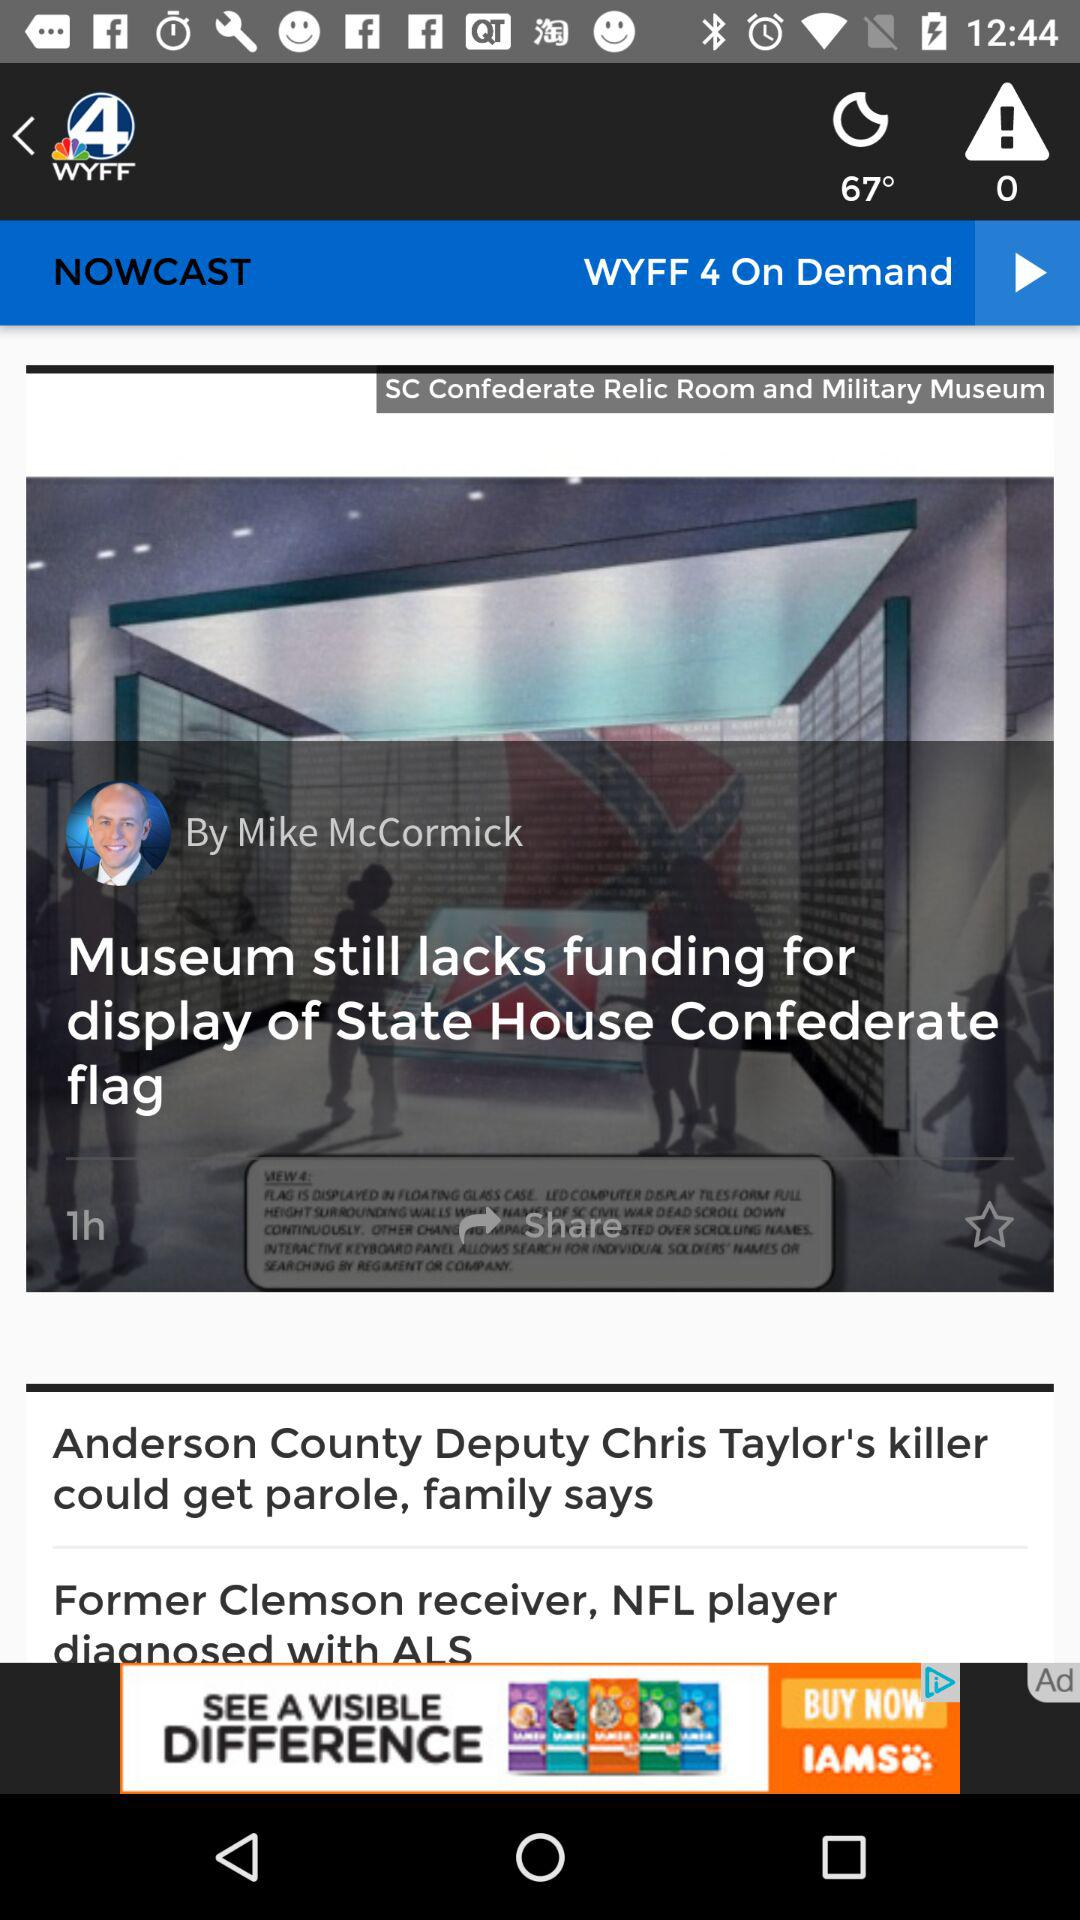What's the weather? The weather is "clear night". 